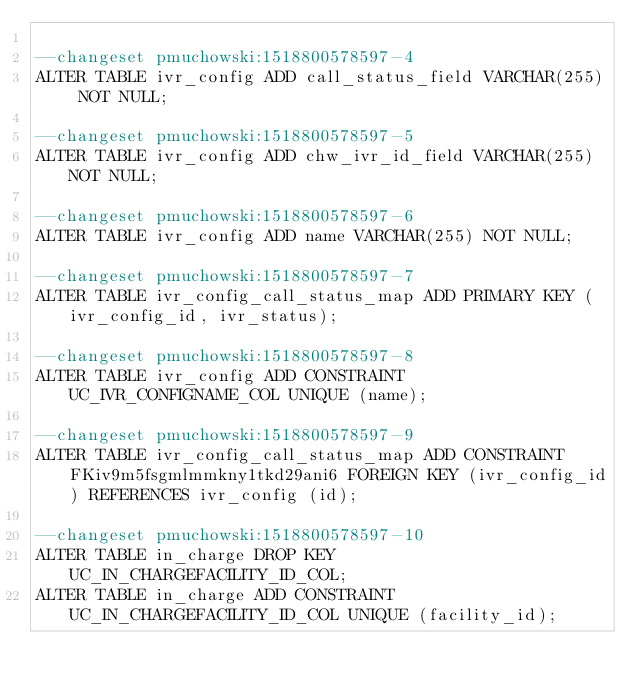Convert code to text. <code><loc_0><loc_0><loc_500><loc_500><_SQL_>
--changeset pmuchowski:1518800578597-4
ALTER TABLE ivr_config ADD call_status_field VARCHAR(255) NOT NULL;

--changeset pmuchowski:1518800578597-5
ALTER TABLE ivr_config ADD chw_ivr_id_field VARCHAR(255) NOT NULL;

--changeset pmuchowski:1518800578597-6
ALTER TABLE ivr_config ADD name VARCHAR(255) NOT NULL;

--changeset pmuchowski:1518800578597-7
ALTER TABLE ivr_config_call_status_map ADD PRIMARY KEY (ivr_config_id, ivr_status);

--changeset pmuchowski:1518800578597-8
ALTER TABLE ivr_config ADD CONSTRAINT UC_IVR_CONFIGNAME_COL UNIQUE (name);

--changeset pmuchowski:1518800578597-9
ALTER TABLE ivr_config_call_status_map ADD CONSTRAINT FKiv9m5fsgmlmmkny1tkd29ani6 FOREIGN KEY (ivr_config_id) REFERENCES ivr_config (id);

--changeset pmuchowski:1518800578597-10
ALTER TABLE in_charge DROP KEY UC_IN_CHARGEFACILITY_ID_COL;
ALTER TABLE in_charge ADD CONSTRAINT UC_IN_CHARGEFACILITY_ID_COL UNIQUE (facility_id);

</code> 